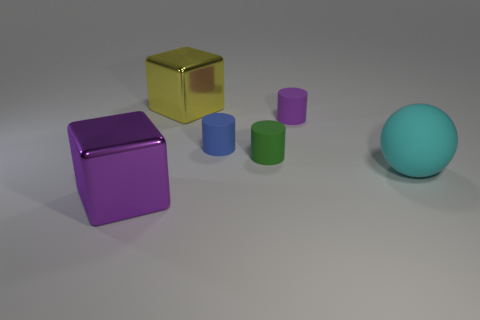How many other large objects have the same material as the large purple object?
Provide a succinct answer. 1. Do the metallic cube that is right of the large purple metallic block and the purple thing that is behind the purple shiny object have the same size?
Provide a succinct answer. No. What material is the big object that is right of the big cube behind the tiny blue rubber cylinder made of?
Provide a short and direct response. Rubber. Is the number of big metallic objects in front of the yellow thing less than the number of large purple cubes that are behind the large cyan rubber ball?
Keep it short and to the point. No. Is there anything else that is the same shape as the tiny purple object?
Make the answer very short. Yes. There is a purple cylinder in front of the big yellow metallic thing; what is its material?
Give a very brief answer. Rubber. Is there any other thing that is the same size as the green object?
Keep it short and to the point. Yes. There is a yellow thing; are there any large cyan rubber things to the left of it?
Keep it short and to the point. No. The large yellow metallic object has what shape?
Ensure brevity in your answer.  Cube. How many things are either large metallic blocks that are in front of the big yellow cube or cylinders?
Offer a terse response. 4. 